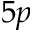Convert formula to latex. <formula><loc_0><loc_0><loc_500><loc_500>5 p</formula> 